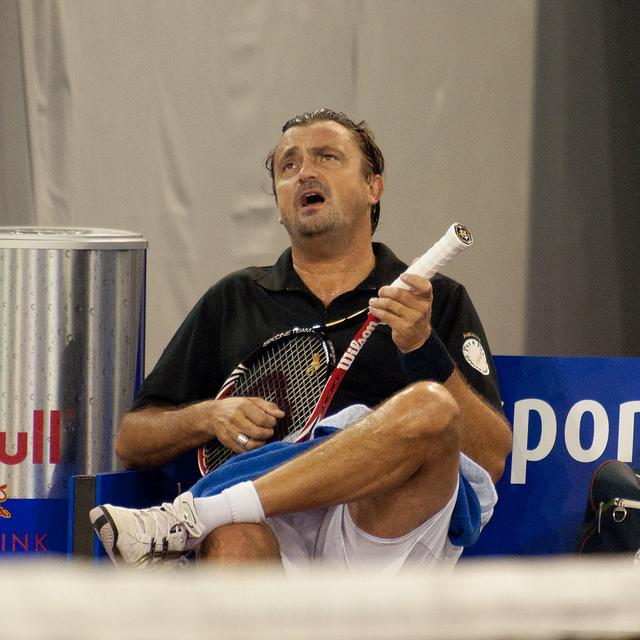He is pretending the tennis racket is what? Please explain your reasoning. guitar. He is holding the racket like a musical instrument. 